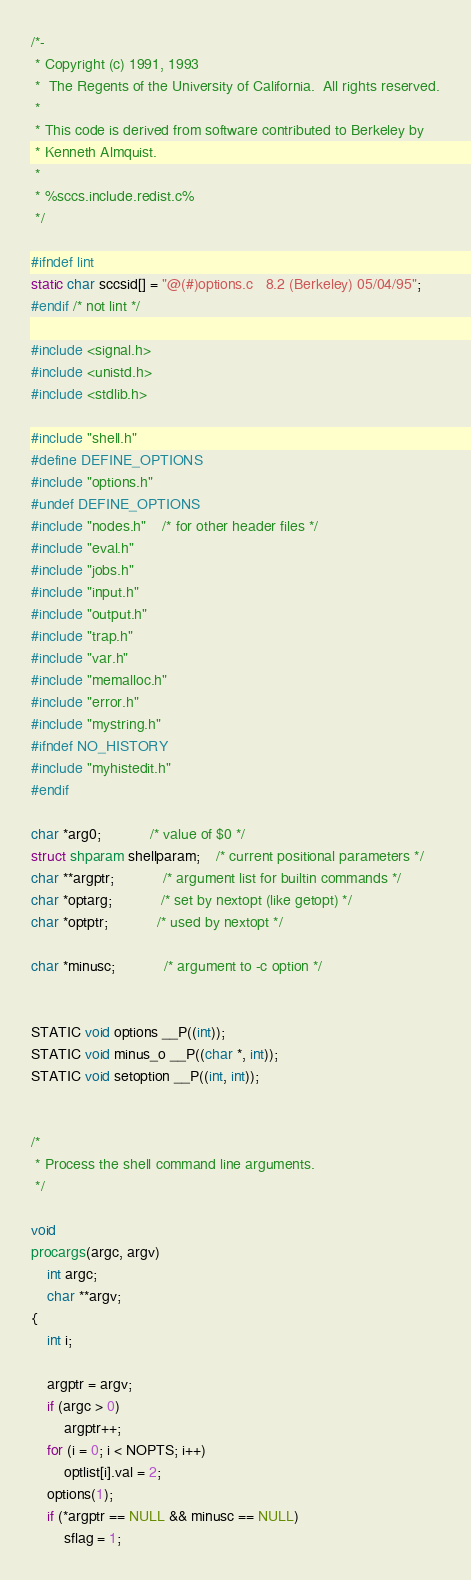<code> <loc_0><loc_0><loc_500><loc_500><_C_>/*-
 * Copyright (c) 1991, 1993
 *	The Regents of the University of California.  All rights reserved.
 *
 * This code is derived from software contributed to Berkeley by
 * Kenneth Almquist.
 *
 * %sccs.include.redist.c%
 */

#ifndef lint
static char sccsid[] = "@(#)options.c	8.2 (Berkeley) 05/04/95";
#endif /* not lint */

#include <signal.h>
#include <unistd.h>
#include <stdlib.h>

#include "shell.h"
#define DEFINE_OPTIONS
#include "options.h"
#undef DEFINE_OPTIONS
#include "nodes.h"	/* for other header files */
#include "eval.h"
#include "jobs.h"
#include "input.h"
#include "output.h"
#include "trap.h"
#include "var.h"
#include "memalloc.h"
#include "error.h"
#include "mystring.h"
#ifndef NO_HISTORY
#include "myhistedit.h"
#endif

char *arg0;			/* value of $0 */
struct shparam shellparam;	/* current positional parameters */
char **argptr;			/* argument list for builtin commands */
char *optarg;			/* set by nextopt (like getopt) */
char *optptr;			/* used by nextopt */

char *minusc;			/* argument to -c option */


STATIC void options __P((int));
STATIC void minus_o __P((char *, int));
STATIC void setoption __P((int, int));


/*
 * Process the shell command line arguments.
 */

void
procargs(argc, argv)
	int argc;
	char **argv;
{
	int i;

	argptr = argv;
	if (argc > 0)
		argptr++;
	for (i = 0; i < NOPTS; i++)
		optlist[i].val = 2;
	options(1);
	if (*argptr == NULL && minusc == NULL)
		sflag = 1;</code> 